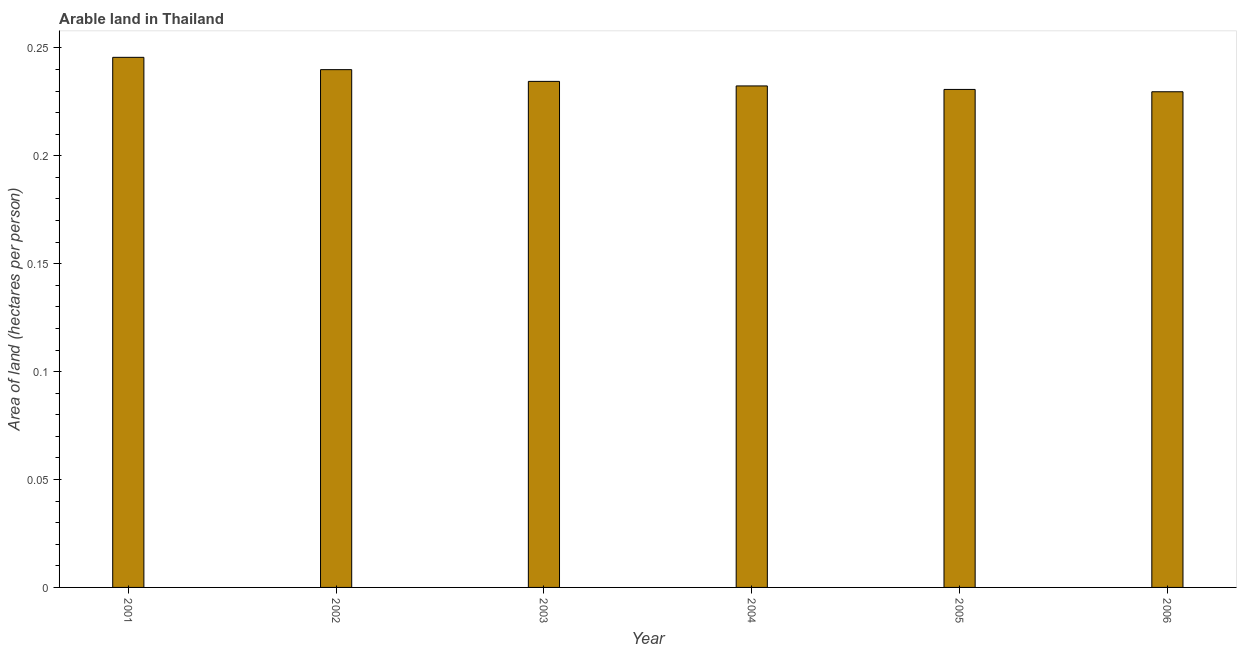Does the graph contain any zero values?
Your response must be concise. No. What is the title of the graph?
Offer a very short reply. Arable land in Thailand. What is the label or title of the X-axis?
Offer a very short reply. Year. What is the label or title of the Y-axis?
Offer a very short reply. Area of land (hectares per person). What is the area of arable land in 2005?
Your response must be concise. 0.23. Across all years, what is the maximum area of arable land?
Your response must be concise. 0.25. Across all years, what is the minimum area of arable land?
Offer a terse response. 0.23. What is the sum of the area of arable land?
Offer a terse response. 1.41. What is the difference between the area of arable land in 2001 and 2006?
Give a very brief answer. 0.02. What is the average area of arable land per year?
Make the answer very short. 0.23. What is the median area of arable land?
Offer a terse response. 0.23. In how many years, is the area of arable land greater than 0.08 hectares per person?
Your answer should be compact. 6. What is the ratio of the area of arable land in 2001 to that in 2005?
Offer a terse response. 1.06. Is the difference between the area of arable land in 2002 and 2004 greater than the difference between any two years?
Provide a succinct answer. No. What is the difference between the highest and the second highest area of arable land?
Offer a terse response. 0.01. Is the sum of the area of arable land in 2002 and 2006 greater than the maximum area of arable land across all years?
Ensure brevity in your answer.  Yes. What is the difference between the highest and the lowest area of arable land?
Your answer should be compact. 0.02. How many bars are there?
Ensure brevity in your answer.  6. How many years are there in the graph?
Ensure brevity in your answer.  6. Are the values on the major ticks of Y-axis written in scientific E-notation?
Offer a very short reply. No. What is the Area of land (hectares per person) in 2001?
Make the answer very short. 0.25. What is the Area of land (hectares per person) of 2002?
Your answer should be very brief. 0.24. What is the Area of land (hectares per person) of 2003?
Your response must be concise. 0.23. What is the Area of land (hectares per person) in 2004?
Your answer should be compact. 0.23. What is the Area of land (hectares per person) of 2005?
Your answer should be very brief. 0.23. What is the Area of land (hectares per person) of 2006?
Offer a terse response. 0.23. What is the difference between the Area of land (hectares per person) in 2001 and 2002?
Keep it short and to the point. 0.01. What is the difference between the Area of land (hectares per person) in 2001 and 2003?
Your answer should be compact. 0.01. What is the difference between the Area of land (hectares per person) in 2001 and 2004?
Offer a terse response. 0.01. What is the difference between the Area of land (hectares per person) in 2001 and 2005?
Give a very brief answer. 0.01. What is the difference between the Area of land (hectares per person) in 2001 and 2006?
Your answer should be compact. 0.02. What is the difference between the Area of land (hectares per person) in 2002 and 2003?
Offer a very short reply. 0.01. What is the difference between the Area of land (hectares per person) in 2002 and 2004?
Make the answer very short. 0.01. What is the difference between the Area of land (hectares per person) in 2002 and 2005?
Provide a succinct answer. 0.01. What is the difference between the Area of land (hectares per person) in 2002 and 2006?
Your answer should be compact. 0.01. What is the difference between the Area of land (hectares per person) in 2003 and 2004?
Ensure brevity in your answer.  0. What is the difference between the Area of land (hectares per person) in 2003 and 2005?
Your response must be concise. 0. What is the difference between the Area of land (hectares per person) in 2003 and 2006?
Your answer should be compact. 0. What is the difference between the Area of land (hectares per person) in 2004 and 2005?
Ensure brevity in your answer.  0. What is the difference between the Area of land (hectares per person) in 2004 and 2006?
Keep it short and to the point. 0. What is the difference between the Area of land (hectares per person) in 2005 and 2006?
Offer a terse response. 0. What is the ratio of the Area of land (hectares per person) in 2001 to that in 2002?
Your answer should be compact. 1.02. What is the ratio of the Area of land (hectares per person) in 2001 to that in 2003?
Give a very brief answer. 1.05. What is the ratio of the Area of land (hectares per person) in 2001 to that in 2004?
Keep it short and to the point. 1.06. What is the ratio of the Area of land (hectares per person) in 2001 to that in 2005?
Provide a short and direct response. 1.06. What is the ratio of the Area of land (hectares per person) in 2001 to that in 2006?
Your response must be concise. 1.07. What is the ratio of the Area of land (hectares per person) in 2002 to that in 2003?
Give a very brief answer. 1.02. What is the ratio of the Area of land (hectares per person) in 2002 to that in 2004?
Your answer should be very brief. 1.03. What is the ratio of the Area of land (hectares per person) in 2002 to that in 2006?
Make the answer very short. 1.04. What is the ratio of the Area of land (hectares per person) in 2003 to that in 2005?
Ensure brevity in your answer.  1.02. What is the ratio of the Area of land (hectares per person) in 2003 to that in 2006?
Make the answer very short. 1.02. What is the ratio of the Area of land (hectares per person) in 2004 to that in 2005?
Make the answer very short. 1.01. 